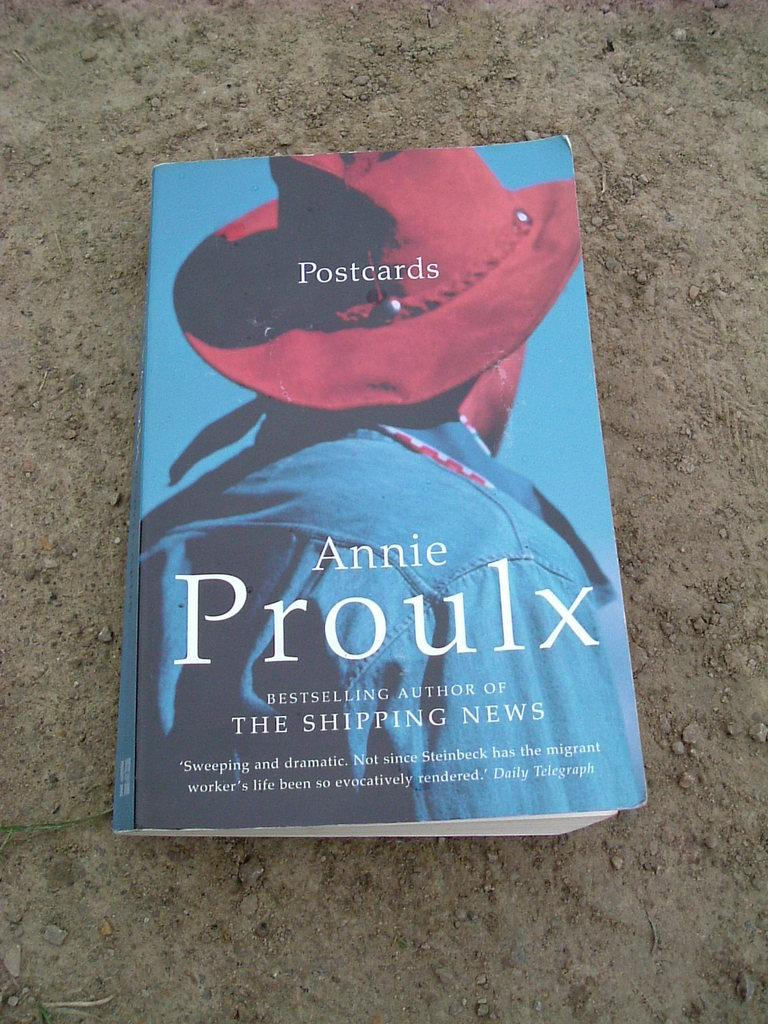What object can be seen in the image? There is a book in the image. Where is the book located? The book is on the land. What date is marked on the calendar in the image? There is no calendar present in the image; it only features a book on the land. 